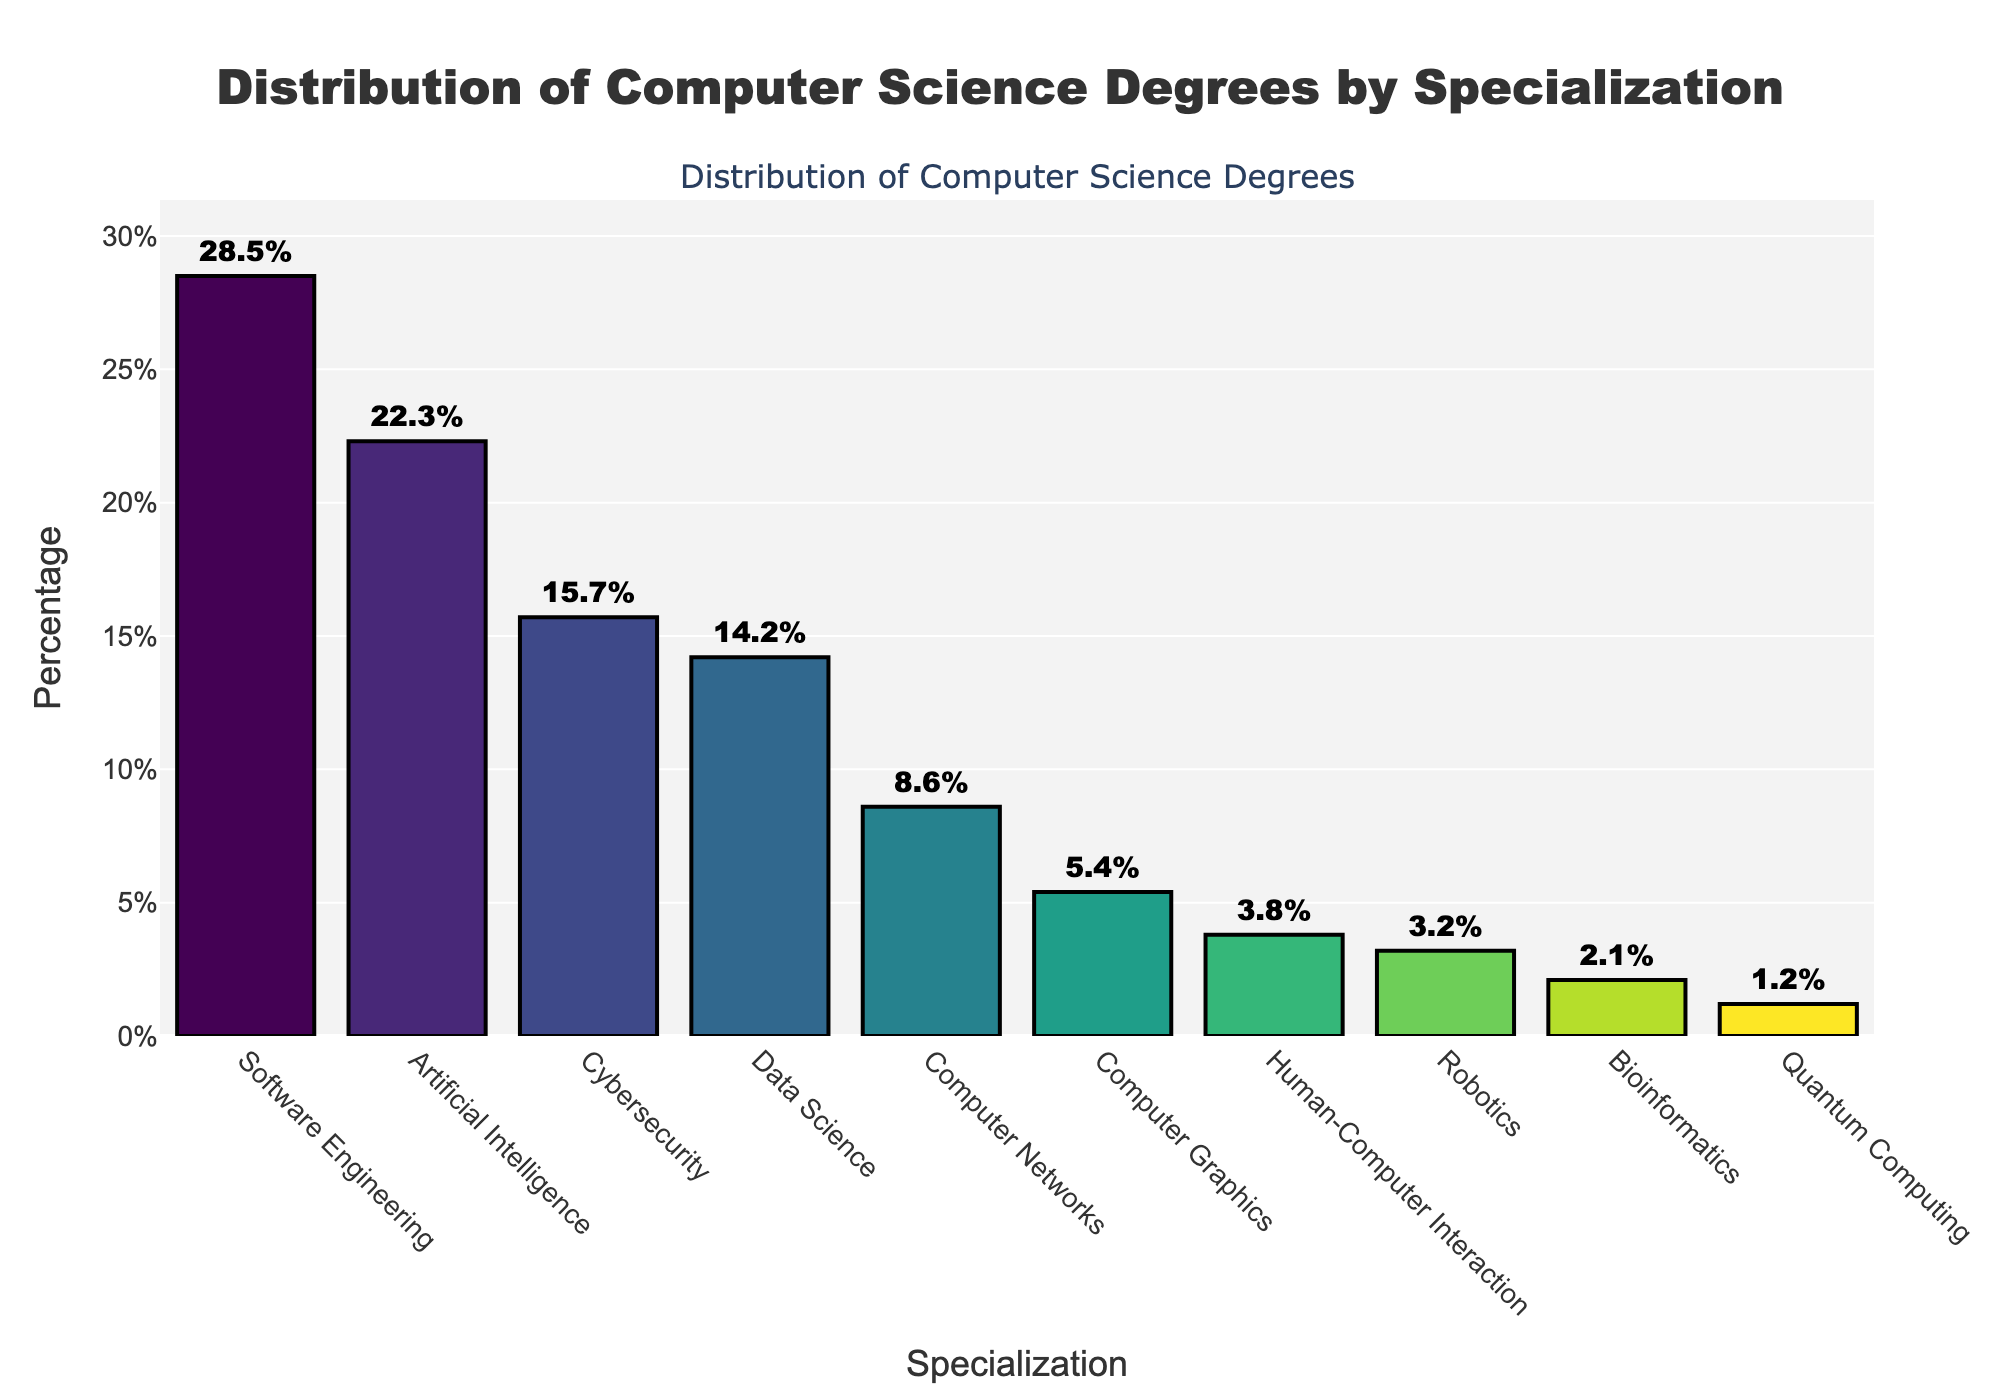What specialization has the highest percentage of degrees awarded? By looking at the bar chart, the tallest bar represents the specialization with the highest percentage. The tallest bar corresponds to Software Engineering.
Answer: Software Engineering Which specialization has a higher percentage of degrees awarded: Cybersecurity or Data Science? By comparing the heights of the bars for Cybersecurity and Data Science, Cybersecurity's bar is taller.
Answer: Cybersecurity What is the total percentage of degrees awarded in Software Engineering and Artificial Intelligence combined? To find the total percentage, add 28.5% (Software Engineering) and 22.3% (Artificial Intelligence). Thus, 28.5 + 22.3 = 50.8%.
Answer: 50.8% How much higher is the percentage of Software Engineering degrees compared to Quantum Computing degrees? Subtract the percentage for Quantum Computing from Software Engineering: 28.5% - 1.2% = 27.3%.
Answer: 27.3% Rank the specializations in descending order based on the percentage of degrees awarded. Arrange the specializations from the bar chart in order from the tallest to shortest bars: Software Engineering, Artificial Intelligence, Cybersecurity, Data Science, Computer Networks, Computer Graphics, Human-Computer Interaction, Robotics, Bioinformatics, Quantum Computing.
Answer: Software Engineering, Artificial Intelligence, Cybersecurity, Data Science, Computer Networks, Computer Graphics, Human-Computer Interaction, Robotics, Bioinformatics, Quantum Computing What is the median percentage of degrees awarded across all specializations? First, list the percentages in ascending order: 1.2%, 2.1%, 3.2%, 3.8%, 5.4%, 8.6%, 14.2%, 15.7%, 22.3%, 28.5%. The median is the middle value, which is the 5th and 6th values averaged: (5.4% + 8.6%) / 2 = 7.0%.
Answer: 7.0% Which specializations are awarded fewer degrees compared to Computer Networks? Compare the height of the Computer Networks bar (8.6%) to other shorter bars: Computer Graphics, Human-Computer Interaction, Robotics, Bioinformatics, Quantum Computing.
Answer: Computer Graphics, Human-Computer Interaction, Robotics, Bioinformatics, Quantum Computing What is the percentage difference between the specializations awarded the most and the least degrees? Subtract the percentage for Quantum Computing from Software Engineering: 28.5% - 1.2% = 27.3%.
Answer: 27.3% What is the average percentage of degrees awarded for all specializations? Sum all the percentages and divide by the number of specializations: (28.5 + 22.3 + 15.7 + 14.2 + 8.6 + 5.4 + 3.8 + 3.2 + 2.1 + 1.2) / 10 = 10.50%.
Answer: 10.5% Which specialization has the least percentage of degrees awarded? By looking at the bar chart, the shortest bar represents the specialization with the least percentage. The shortest bar corresponds to Quantum Computing.
Answer: Quantum Computing 